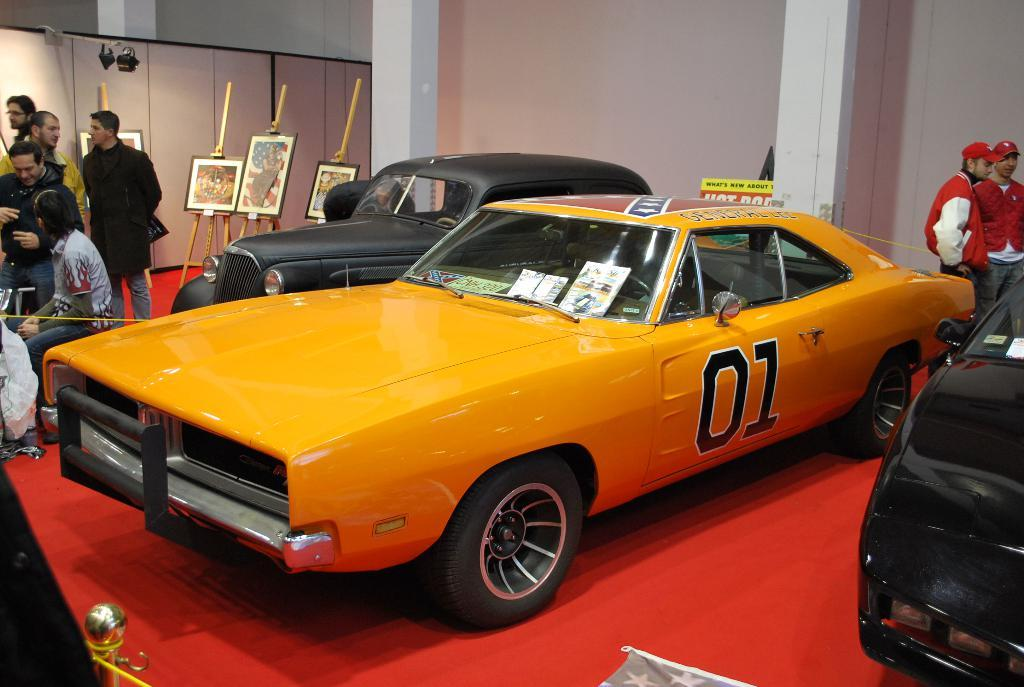What type of surface are the vehicles on in the image? The vehicles are on a red surface in the image. Can you describe the people in the image? There are people in the image, but their specific actions or appearances are not mentioned in the facts. What can be seen in the image that might provide illumination? There are lights in the image. What type of structure is present in the image? There is a wall in the image. What objects are on stands in the image? There are boards on stands in the image. What color is the crayon being used by the person in the image? There is no mention of a crayon or any drawing activity in the image, so it cannot be determined. How many muscles are visible on the people in the image? The facts do not provide information about the people's muscles, so it cannot be determined. 